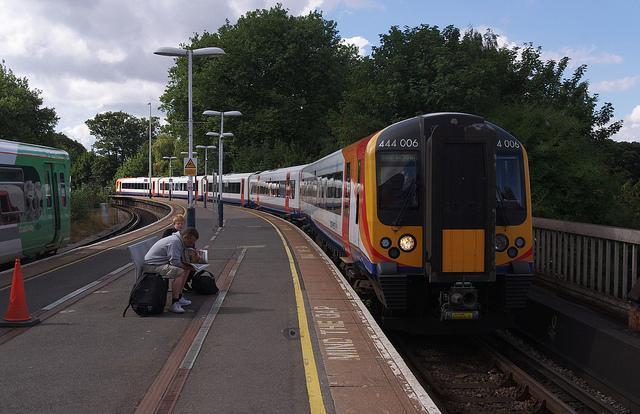How many trains are in the picture?
Give a very brief answer. 2. 